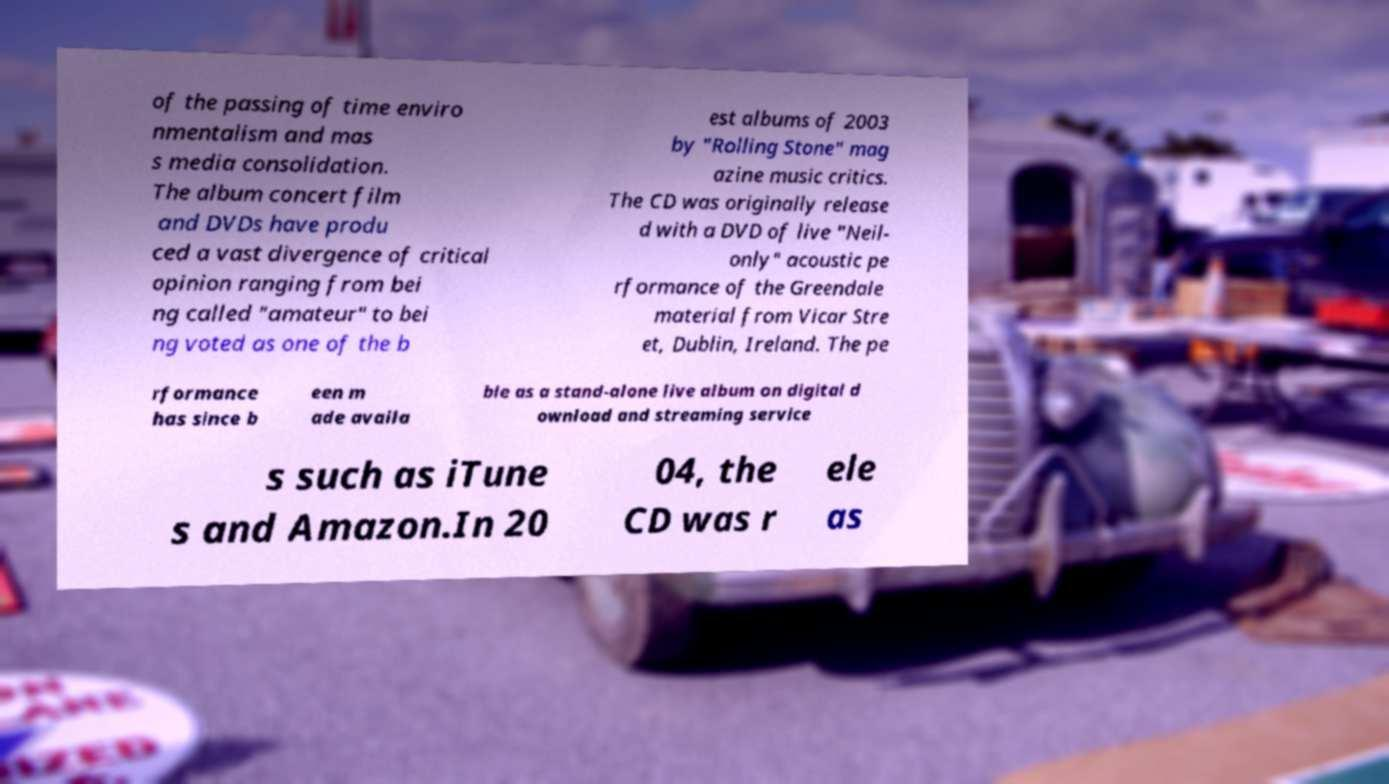I need the written content from this picture converted into text. Can you do that? of the passing of time enviro nmentalism and mas s media consolidation. The album concert film and DVDs have produ ced a vast divergence of critical opinion ranging from bei ng called "amateur" to bei ng voted as one of the b est albums of 2003 by "Rolling Stone" mag azine music critics. The CD was originally release d with a DVD of live "Neil- only" acoustic pe rformance of the Greendale material from Vicar Stre et, Dublin, Ireland. The pe rformance has since b een m ade availa ble as a stand-alone live album on digital d ownload and streaming service s such as iTune s and Amazon.In 20 04, the CD was r ele as 